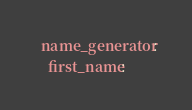Convert code to text. <code><loc_0><loc_0><loc_500><loc_500><_YAML_>  name_generator:
    first_name:</code> 